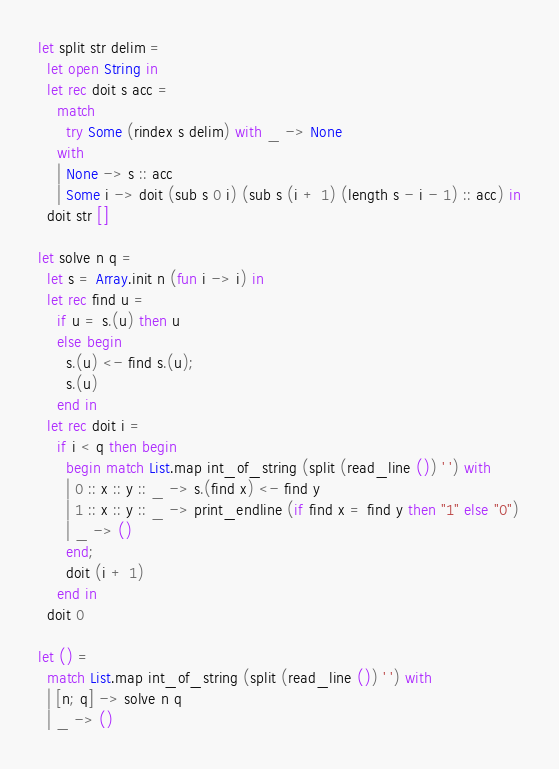<code> <loc_0><loc_0><loc_500><loc_500><_OCaml_>let split str delim =
  let open String in
  let rec doit s acc =
    match
      try Some (rindex s delim) with _ -> None
    with
    | None -> s :: acc
    | Some i -> doit (sub s 0 i) (sub s (i + 1) (length s - i - 1) :: acc) in
  doit str []

let solve n q =
  let s = Array.init n (fun i -> i) in
  let rec find u =
    if u = s.(u) then u
    else begin
      s.(u) <- find s.(u);
      s.(u)
    end in
  let rec doit i =
    if i < q then begin
      begin match List.map int_of_string (split (read_line ()) ' ') with
      | 0 :: x :: y :: _ -> s.(find x) <- find y
      | 1 :: x :: y :: _ -> print_endline (if find x = find y then "1" else "0")
      | _ -> ()
      end;
      doit (i + 1)
    end in
  doit 0

let () =
  match List.map int_of_string (split (read_line ()) ' ') with
  | [n; q] -> solve n q
  | _ -> ()</code> 